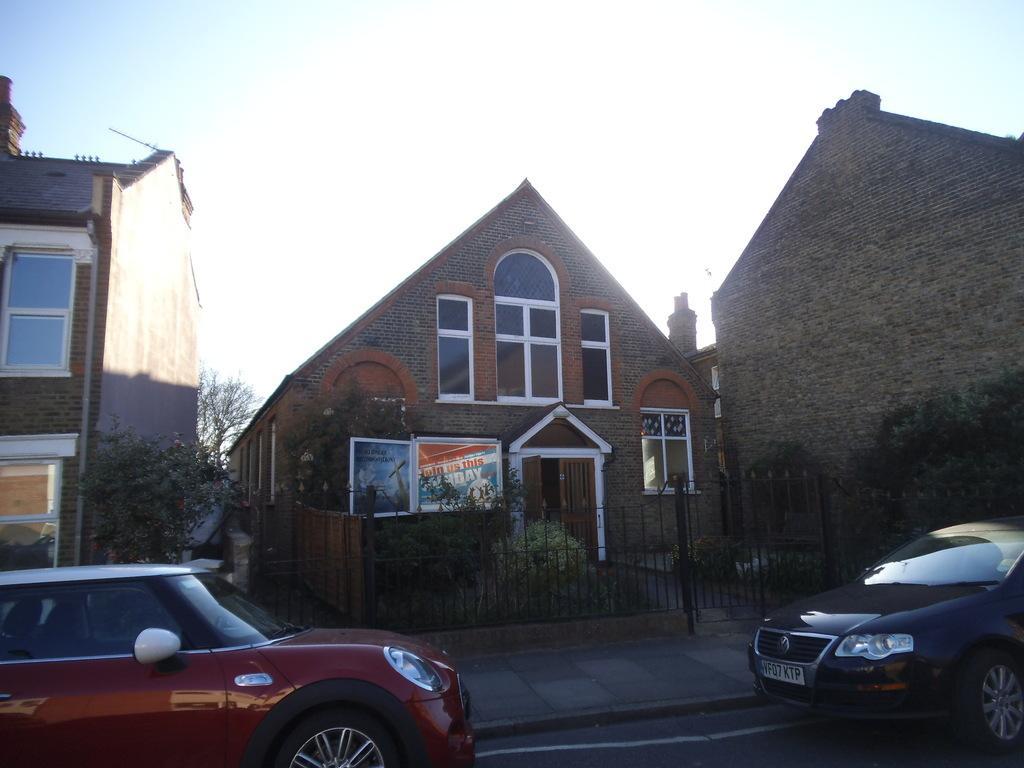How would you summarize this image in a sentence or two? In this image I can see a road in the front and on it I can see two cars. In the background I can see few buildings, few boards, fencing, number of trees and the sky. I can also see something is written on these boards. 